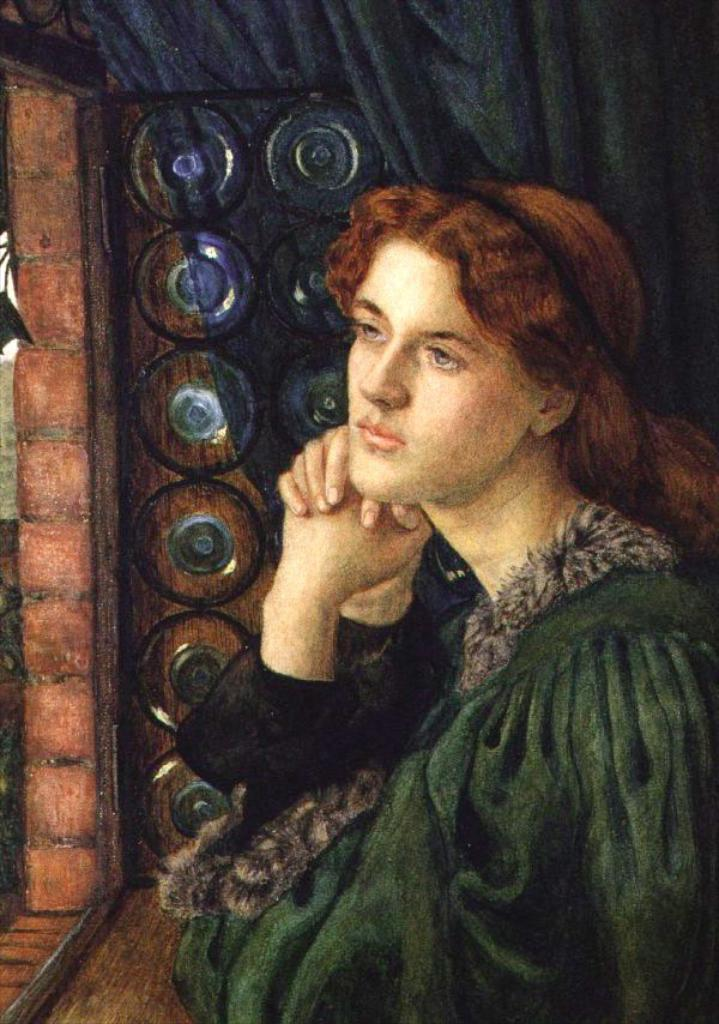What is the main subject of the image? The main subject of the image is a painting. What type of egg can be seen in the painting? There is no egg present in the painting; the image only contains a painting. How many curves can be seen in the throat of the person depicted in the painting? There is no person depicted in the painting, and therefore no throat or curves can be observed. 